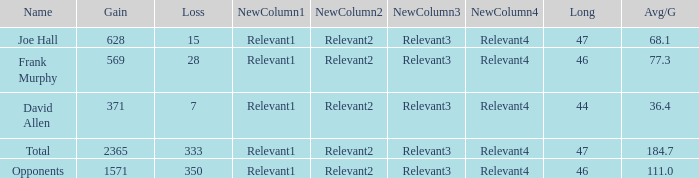Which Avg/G is the lowest one that has a Long smaller than 47, and a Name of frank murphy, and a Gain smaller than 569? None. 